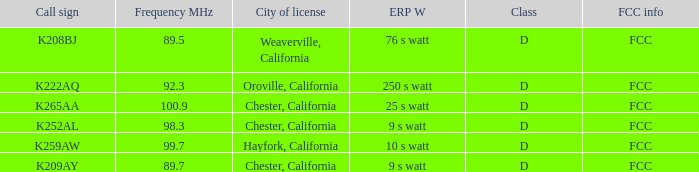Name the call sign with frequency of 89.5 K208BJ. 